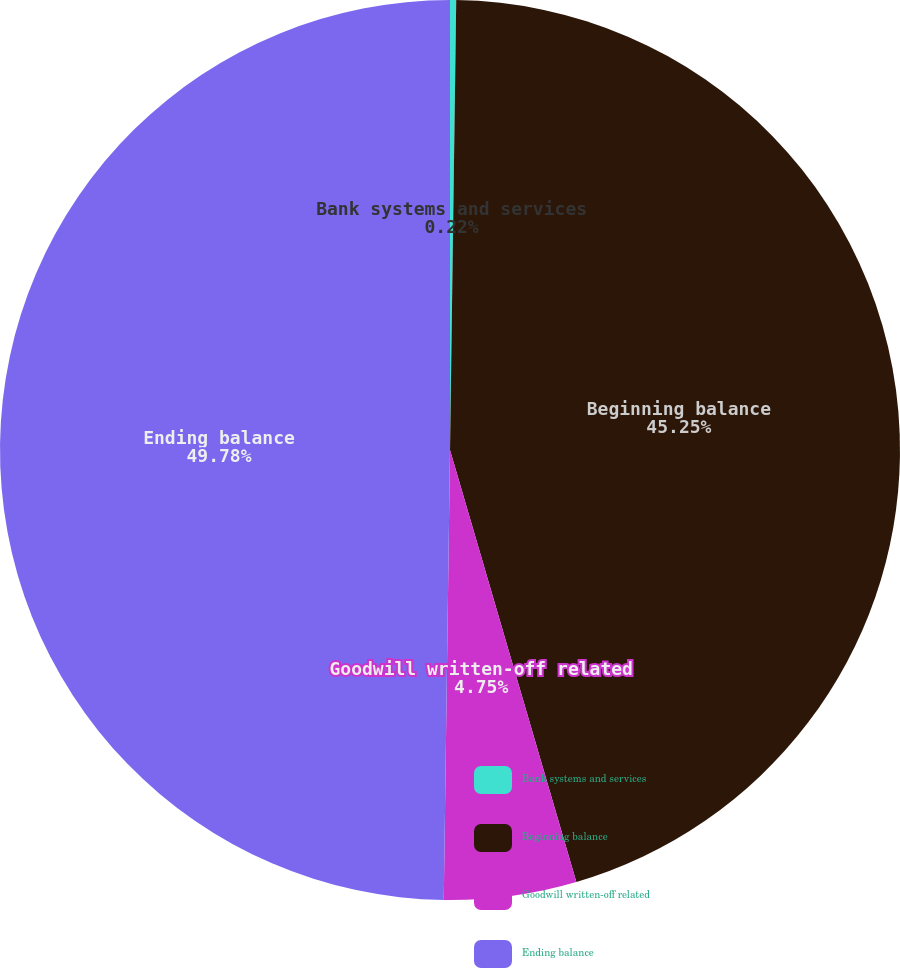Convert chart. <chart><loc_0><loc_0><loc_500><loc_500><pie_chart><fcel>Bank systems and services<fcel>Beginning balance<fcel>Goodwill written-off related<fcel>Ending balance<nl><fcel>0.22%<fcel>45.25%<fcel>4.75%<fcel>49.78%<nl></chart> 